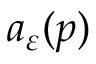Convert formula to latex. <formula><loc_0><loc_0><loc_500><loc_500>a _ { \varepsilon } ( p )</formula> 